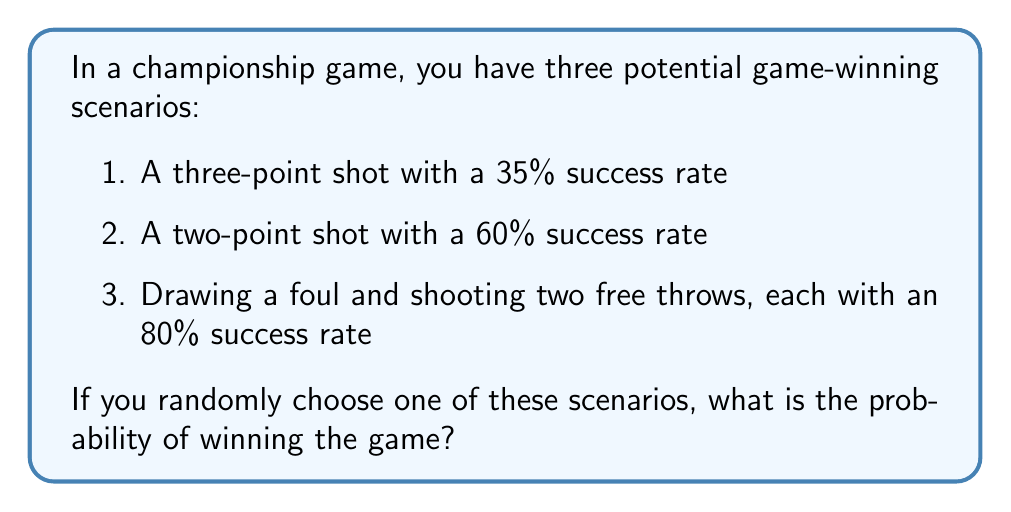Can you solve this math problem? Let's approach this step-by-step:

1) First, we need to calculate the probability of success for each scenario:

   a) Three-point shot: Given as 35% or 0.35
   
   b) Two-point shot: Given as 60% or 0.60
   
   c) Free throws: We need to calculate the probability of making at least one of the two free throws.
      Probability of missing both = $0.2 \times 0.2 = 0.04$
      Probability of making at least one = $1 - 0.04 = 0.96$ or 96%

2) Now, we have three scenarios with their respective probabilities:
   - Scenario 1: 0.35
   - Scenario 2: 0.60
   - Scenario 3: 0.96

3) Since we're randomly choosing one of these scenarios, each has an equal probability of being selected, which is $\frac{1}{3}$.

4) To calculate the overall probability of winning, we use the law of total probability:

   $$P(\text{winning}) = P(\text{Scenario 1}) \times P(\text{winning|Scenario 1}) + \\
                         P(\text{Scenario 2}) \times P(\text{winning|Scenario 2}) + \\
                         P(\text{Scenario 3}) \times P(\text{winning|Scenario 3})$$

   $$P(\text{winning}) = \frac{1}{3} \times 0.35 + \frac{1}{3} \times 0.60 + \frac{1}{3} \times 0.96$$

5) Calculating:
   $$P(\text{winning}) = \frac{0.35 + 0.60 + 0.96}{3} = \frac{1.91}{3} = 0.6367$$

Therefore, the probability of winning the game by randomly choosing one of these scenarios is approximately 0.6367 or 63.67%.
Answer: 0.6367 or 63.67% 